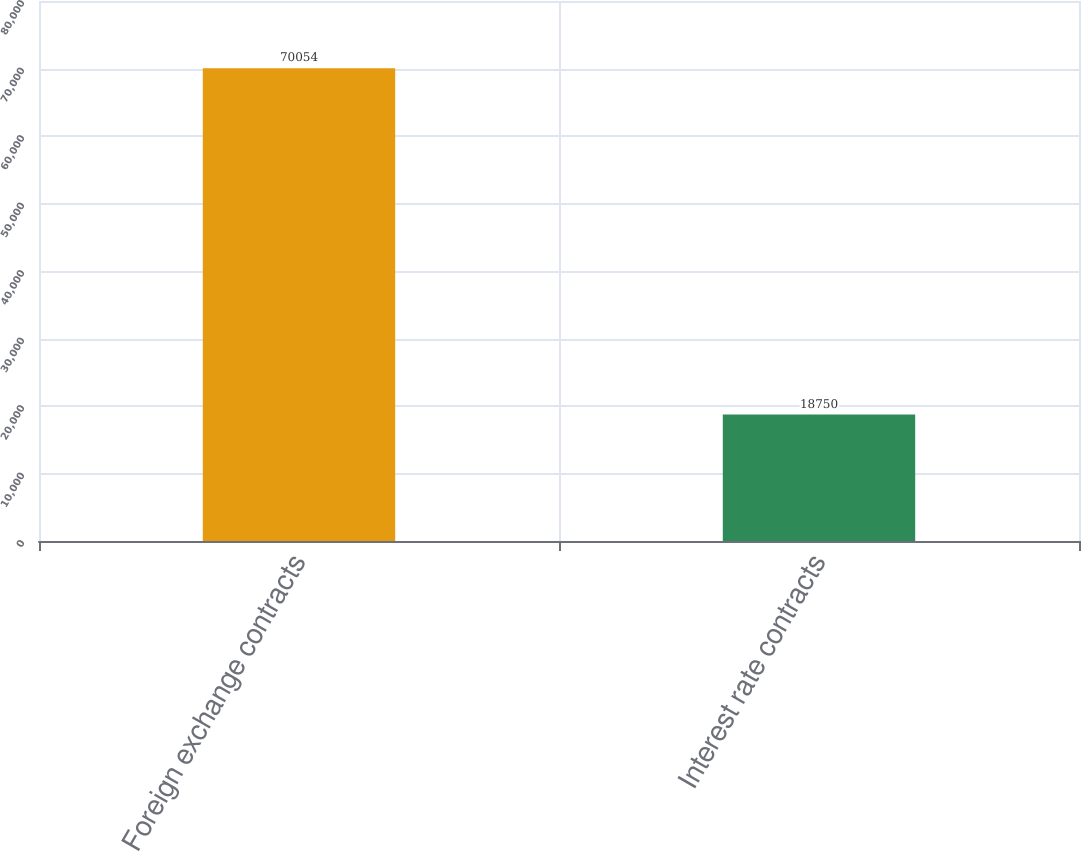Convert chart. <chart><loc_0><loc_0><loc_500><loc_500><bar_chart><fcel>Foreign exchange contracts<fcel>Interest rate contracts<nl><fcel>70054<fcel>18750<nl></chart> 